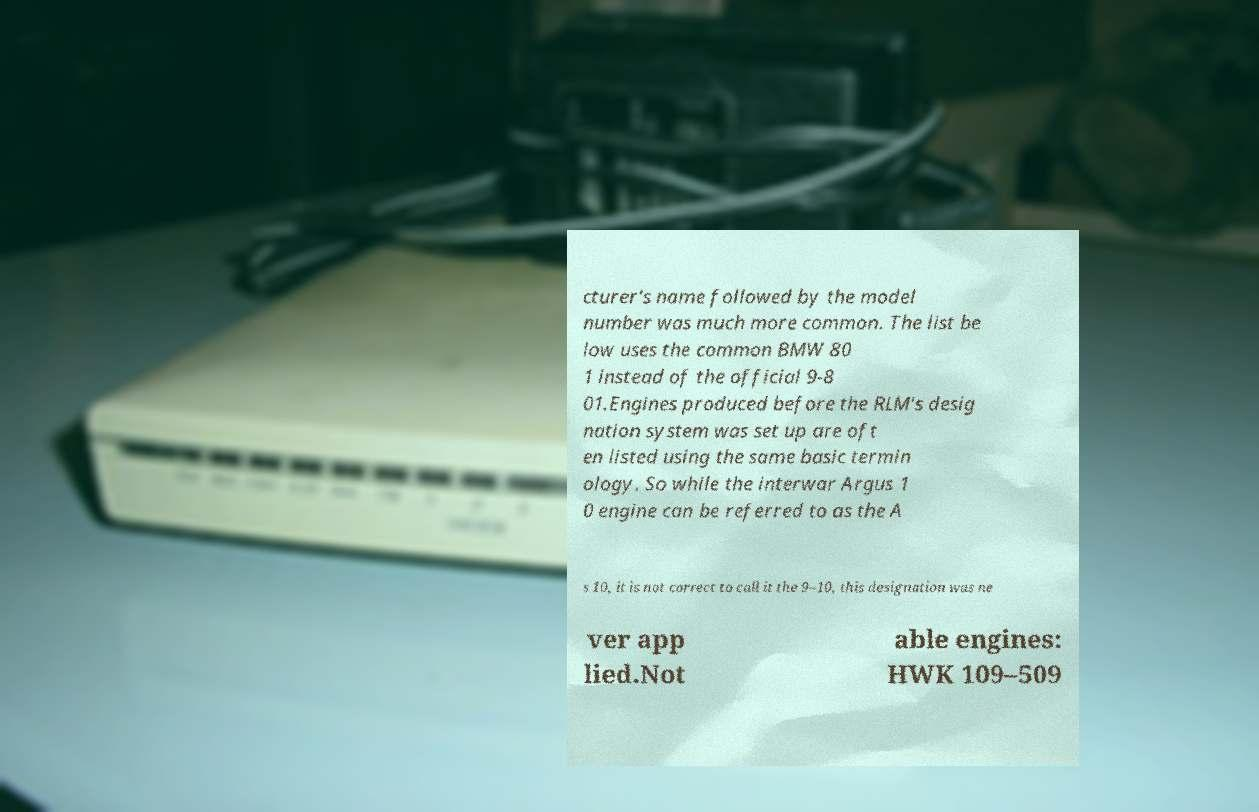Please read and relay the text visible in this image. What does it say? cturer's name followed by the model number was much more common. The list be low uses the common BMW 80 1 instead of the official 9-8 01.Engines produced before the RLM's desig nation system was set up are oft en listed using the same basic termin ology. So while the interwar Argus 1 0 engine can be referred to as the A s 10, it is not correct to call it the 9–10, this designation was ne ver app lied.Not able engines: HWK 109–509 